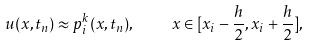<formula> <loc_0><loc_0><loc_500><loc_500>u ( x , t _ { n } ) \approx p _ { i } ^ { k } ( x , t _ { n } ) , \quad x \in [ x _ { i } - \frac { h } { 2 } , x _ { i } + \frac { h } { 2 } ] ,</formula> 